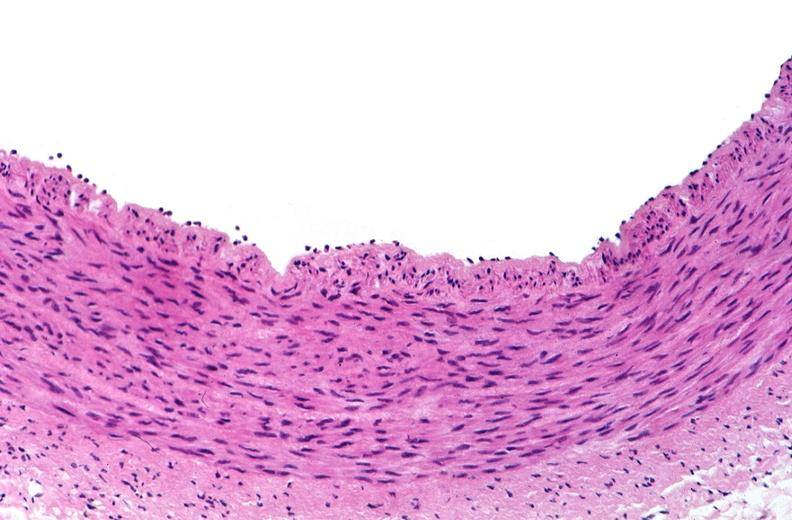does this image show acute inflammation, rolling leukocytes polymorphonuclear neutrophils?
Answer the question using a single word or phrase. Yes 